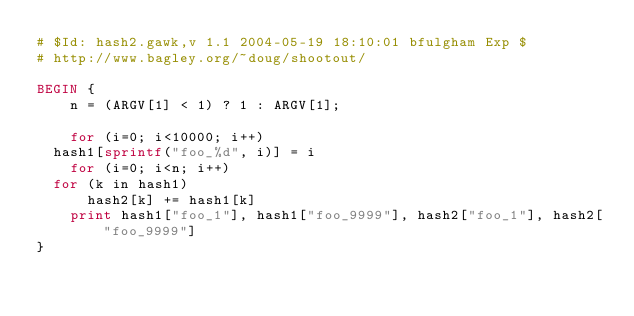Convert code to text. <code><loc_0><loc_0><loc_500><loc_500><_Awk_># $Id: hash2.gawk,v 1.1 2004-05-19 18:10:01 bfulgham Exp $
# http://www.bagley.org/~doug/shootout/

BEGIN {
    n = (ARGV[1] < 1) ? 1 : ARGV[1];

    for (i=0; i<10000; i++)
	hash1[sprintf("foo_%d", i)] = i
    for (i=0; i<n; i++)
	for (k in hash1)
	    hash2[k] += hash1[k]
    print hash1["foo_1"], hash1["foo_9999"], hash2["foo_1"], hash2["foo_9999"]
}
</code> 